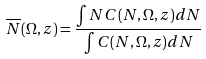<formula> <loc_0><loc_0><loc_500><loc_500>\overline { N } ( \Omega , z ) = \frac { \int N C ( N , \Omega , z ) d N } { \int C ( N , \Omega , z ) d N }</formula> 